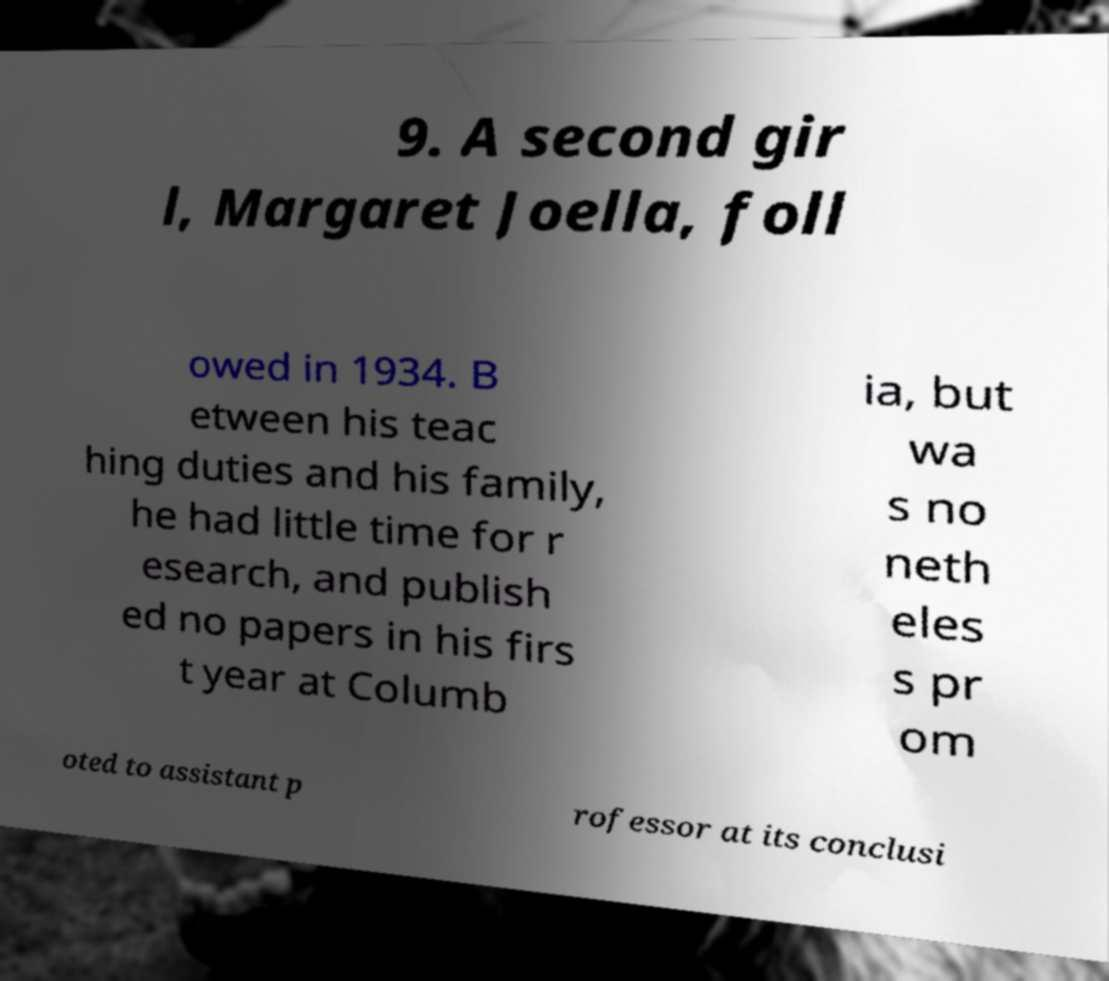For documentation purposes, I need the text within this image transcribed. Could you provide that? 9. A second gir l, Margaret Joella, foll owed in 1934. B etween his teac hing duties and his family, he had little time for r esearch, and publish ed no papers in his firs t year at Columb ia, but wa s no neth eles s pr om oted to assistant p rofessor at its conclusi 